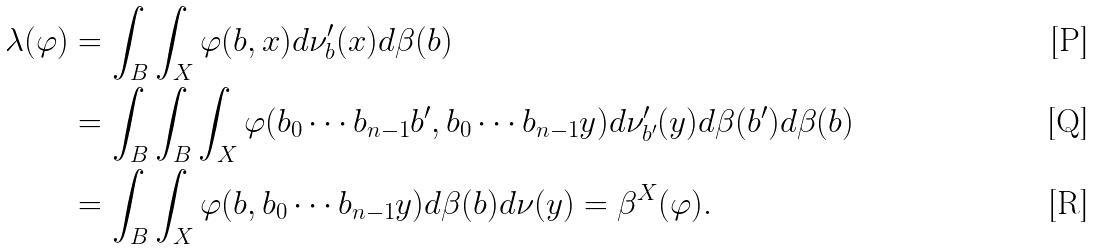Convert formula to latex. <formula><loc_0><loc_0><loc_500><loc_500>\lambda ( \varphi ) & = \int _ { B } \int _ { X } \varphi ( b , x ) d \nu ^ { \prime } _ { b } ( x ) d \beta ( b ) \\ & = \int _ { B } \int _ { B } \int _ { X } \varphi ( b _ { 0 } \cdots b _ { n - 1 } b ^ { \prime } , b _ { 0 } \cdots b _ { n - 1 } y ) d \nu ^ { \prime } _ { b ^ { \prime } } ( y ) d \beta ( b ^ { \prime } ) d \beta ( b ) \\ & = \int _ { B } \int _ { X } \varphi ( b , b _ { 0 } \cdots b _ { n - 1 } y ) d \beta ( b ) d \nu ( y ) = \beta ^ { X } ( \varphi ) .</formula> 